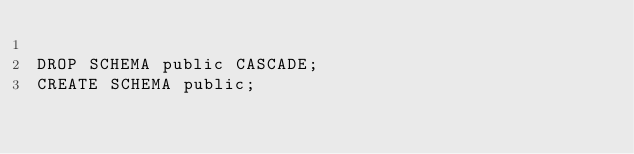Convert code to text. <code><loc_0><loc_0><loc_500><loc_500><_SQL_>
DROP SCHEMA public CASCADE;
CREATE SCHEMA public;
</code> 